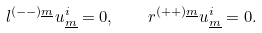<formula> <loc_0><loc_0><loc_500><loc_500>l ^ { ( - - ) \underline { m } } u ^ { i } _ { \underline { m } } = 0 , \quad r ^ { ( + + ) \underline { m } } u ^ { i } _ { \underline { m } } = 0 .</formula> 